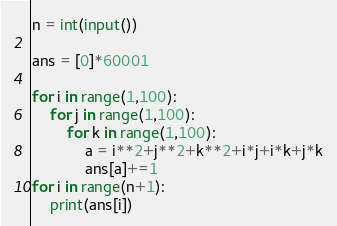Convert code to text. <code><loc_0><loc_0><loc_500><loc_500><_Python_>n = int(input())

ans = [0]*60001

for i in range(1,100):
    for j in range(1,100):
        for k in range(1,100):
            a = i**2+j**2+k**2+i*j+i*k+j*k
            ans[a]+=1
for i in range(n+1):
    print(ans[i])
</code> 